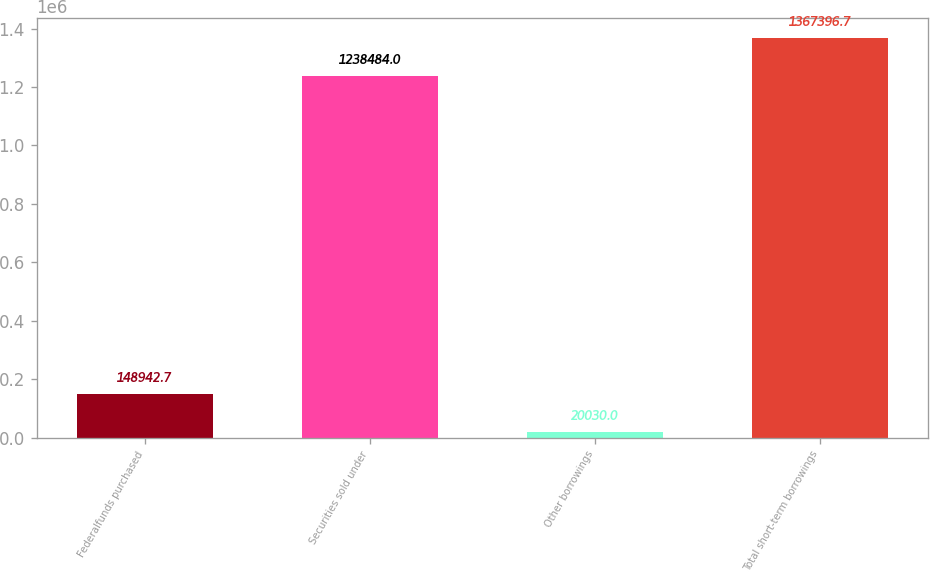Convert chart to OTSL. <chart><loc_0><loc_0><loc_500><loc_500><bar_chart><fcel>Federalfunds purchased<fcel>Securities sold under<fcel>Other borrowings<fcel>Total short-term borrowings<nl><fcel>148943<fcel>1.23848e+06<fcel>20030<fcel>1.3674e+06<nl></chart> 